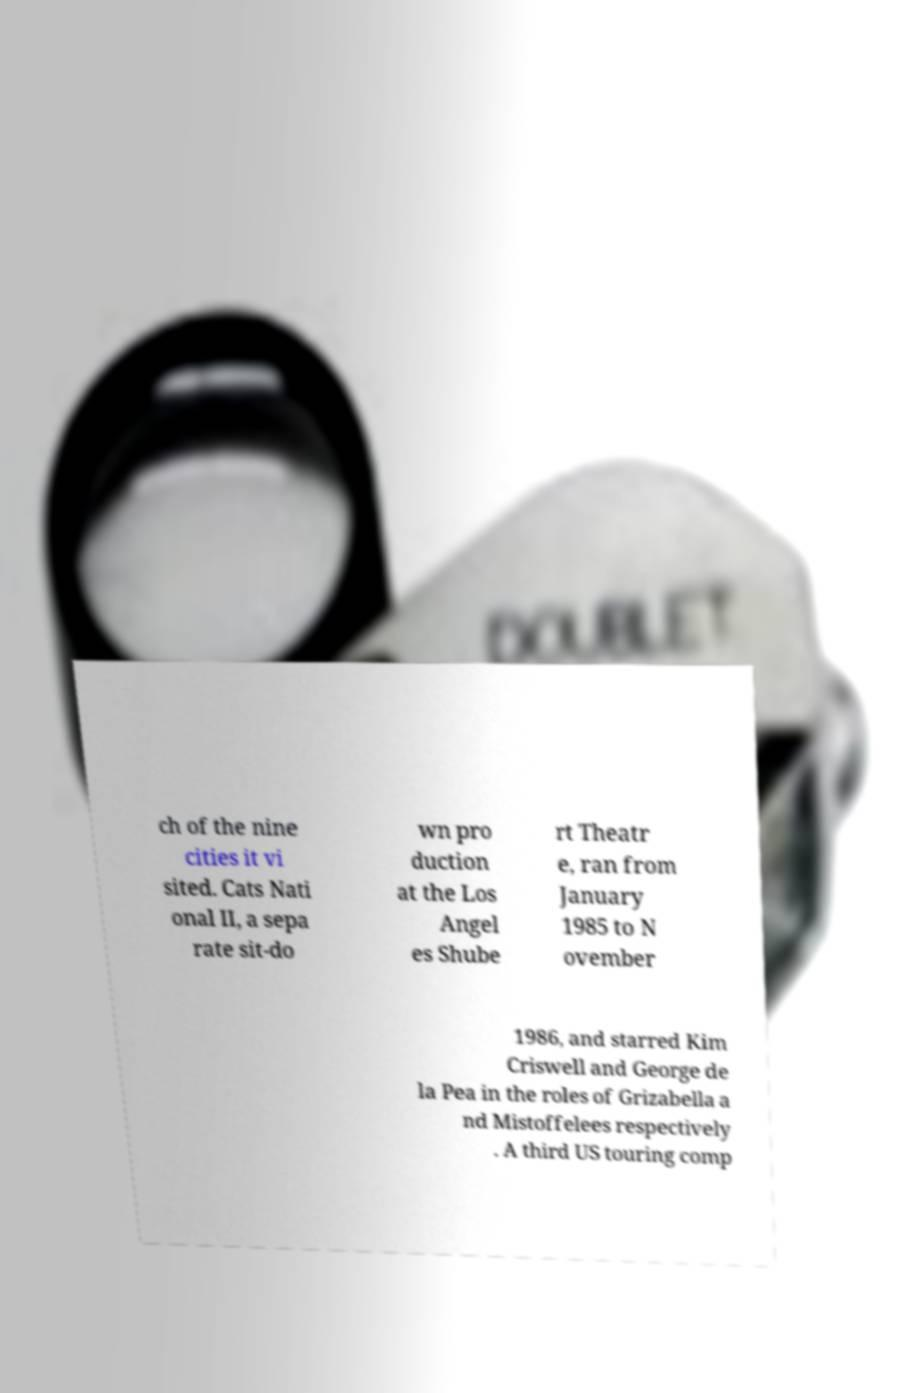There's text embedded in this image that I need extracted. Can you transcribe it verbatim? ch of the nine cities it vi sited. Cats Nati onal II, a sepa rate sit-do wn pro duction at the Los Angel es Shube rt Theatr e, ran from January 1985 to N ovember 1986, and starred Kim Criswell and George de la Pea in the roles of Grizabella a nd Mistoffelees respectively . A third US touring comp 